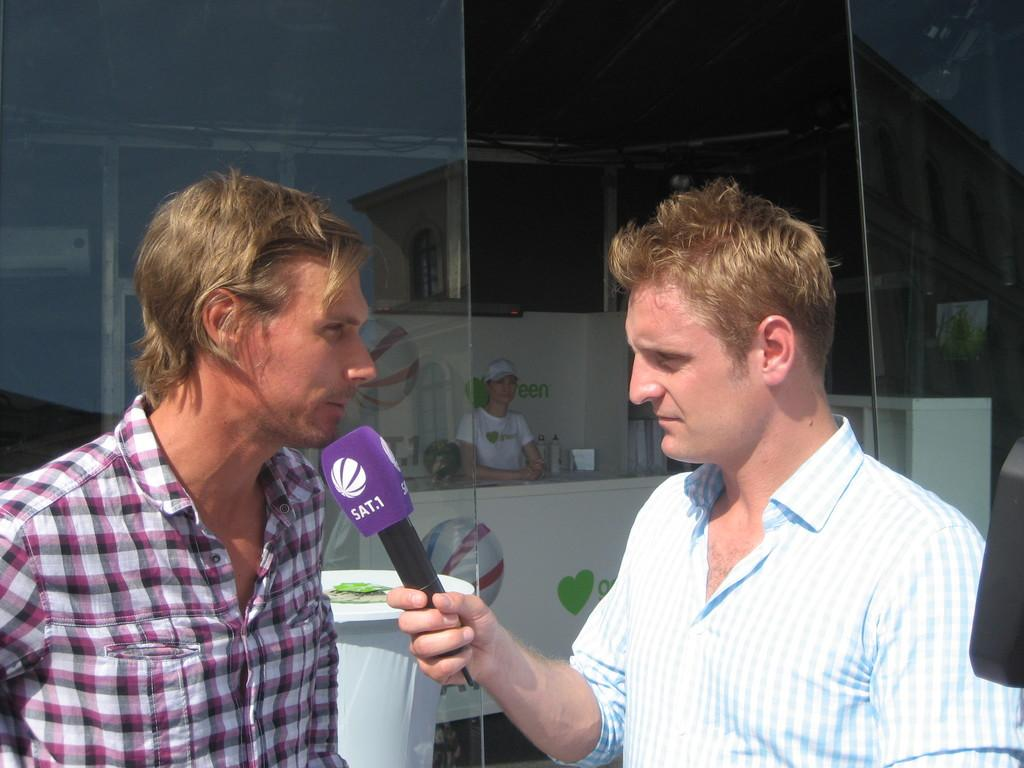What is present on the table in the image? There are glasses on the table in the image. How many people are in the image? There are two people in the image. Can you describe one of the people in the image? One of the people is a man, and he is standing on the right side. What is the man holding in the image? The man is holding a mic in the image. What type of wire is visible in the image? There is no wire present in the image. Can you describe the contents of the drawer in the image? There is no drawer present in the image. 